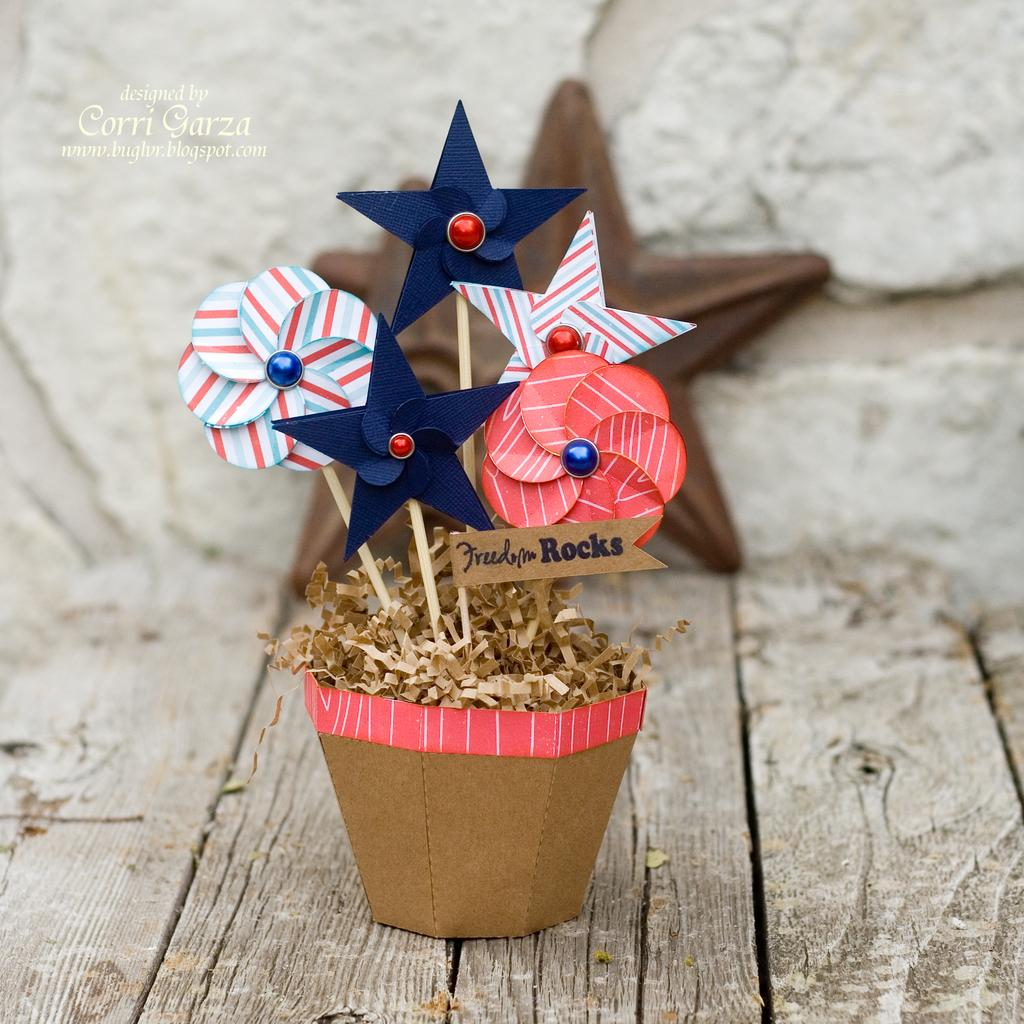What type of craft is depicted in the image? There is a paper craft in the image. What shape is the paper craft? The paper craft is in the shape of a flower pot. What other objects are present in the image? There are flowers in the image. What is the surface made of that the flowers are on? The flowers are on a wooden surface. Can you describe the alley in the background of the image? There is no alley present in the image; it features a paper craft in the shape of a flower pot with flowers on a wooden surface. 